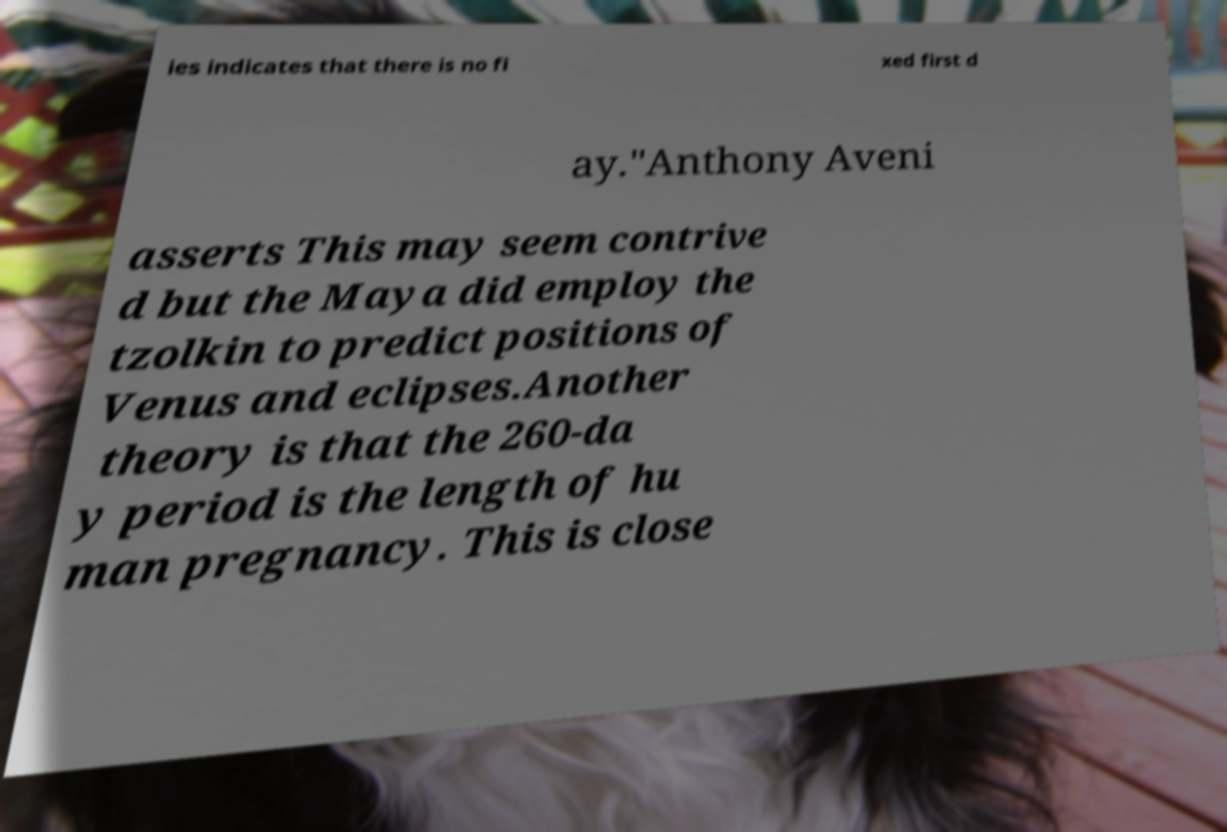Can you accurately transcribe the text from the provided image for me? ies indicates that there is no fi xed first d ay."Anthony Aveni asserts This may seem contrive d but the Maya did employ the tzolkin to predict positions of Venus and eclipses.Another theory is that the 260-da y period is the length of hu man pregnancy. This is close 